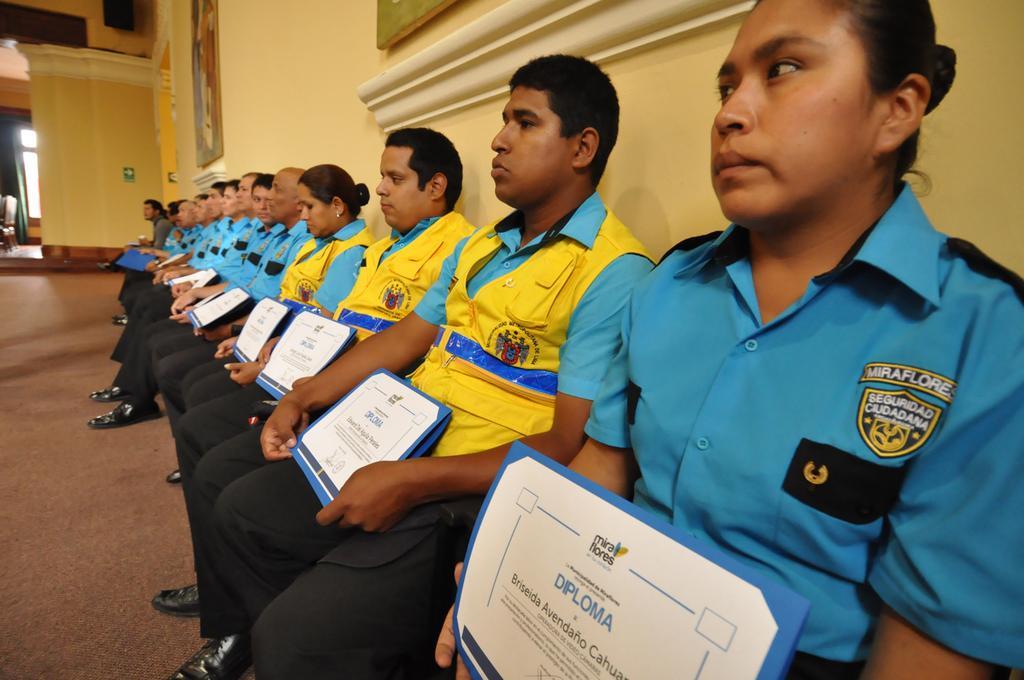How would you summarize this image in a sentence or two? In this picture we can see some people sitting and holding certificates, in the background there is a wall, these people wore shoes. 